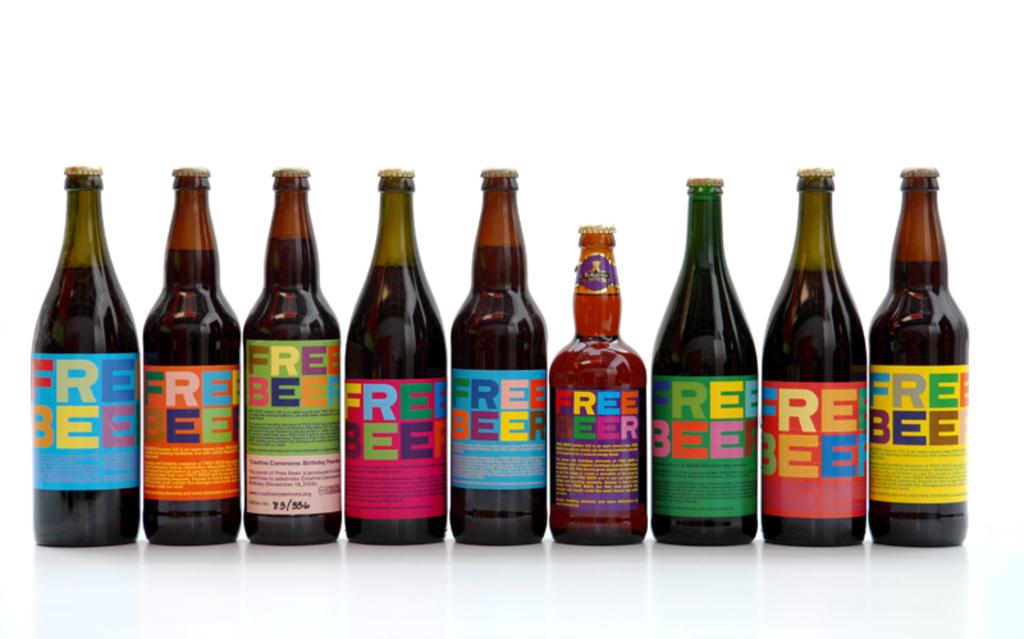What types of items are present in the image? There are different types of beer bottles in the image. Can you describe the appearance of the beer bottles? The beer bottles come in various shapes and sizes, with different labels and colors. How many beer bottles can be seen in the image? The number of beer bottles in the image is not specified, but there are multiple bottles visible. What type of lettuce is being used to perform arithmetic calculations in the image? There is no lettuce or arithmetic calculations present in the image; it only features different types of beer bottles. 